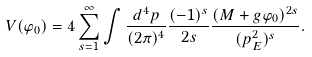<formula> <loc_0><loc_0><loc_500><loc_500>V ( \varphi _ { 0 } ) = 4 \sum _ { s = 1 } ^ { \infty } \int \frac { d ^ { 4 } p } { ( 2 \pi ) ^ { 4 } } \frac { ( - 1 ) ^ { s } } { 2 s } \frac { ( M + g \varphi _ { 0 } ) ^ { 2 s } } { ( p _ { E } ^ { 2 } ) ^ { s } } .</formula> 